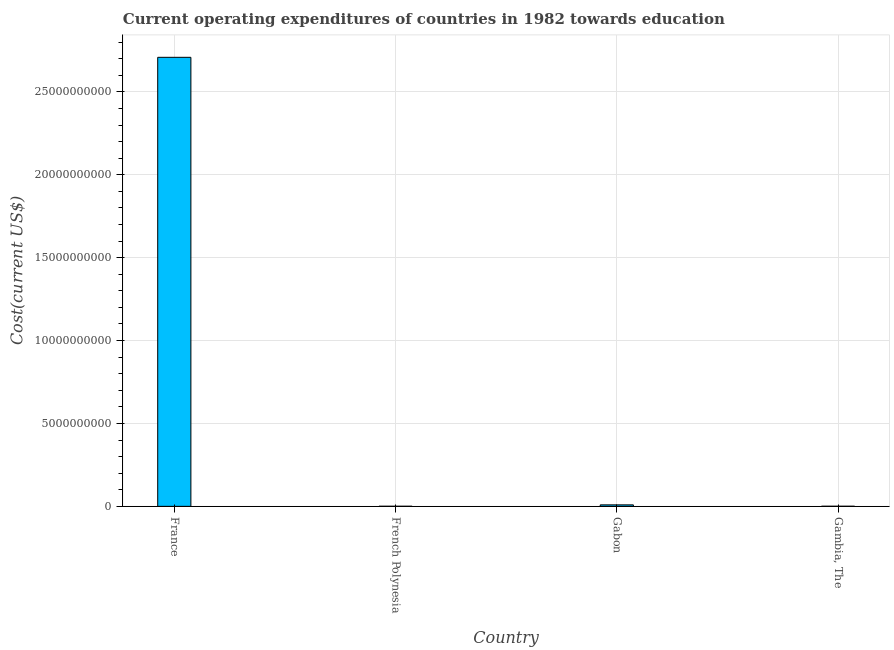Does the graph contain grids?
Provide a short and direct response. Yes. What is the title of the graph?
Provide a short and direct response. Current operating expenditures of countries in 1982 towards education. What is the label or title of the X-axis?
Keep it short and to the point. Country. What is the label or title of the Y-axis?
Your response must be concise. Cost(current US$). What is the education expenditure in Gambia, The?
Provide a succinct answer. 6.18e+06. Across all countries, what is the maximum education expenditure?
Your answer should be compact. 2.71e+1. Across all countries, what is the minimum education expenditure?
Provide a succinct answer. 5.22e+06. In which country was the education expenditure minimum?
Your answer should be compact. French Polynesia. What is the sum of the education expenditure?
Offer a very short reply. 2.72e+1. What is the difference between the education expenditure in French Polynesia and Gambia, The?
Your answer should be very brief. -9.63e+05. What is the average education expenditure per country?
Your answer should be compact. 6.80e+09. What is the median education expenditure?
Provide a short and direct response. 4.77e+07. In how many countries, is the education expenditure greater than 5000000000 US$?
Ensure brevity in your answer.  1. What is the ratio of the education expenditure in French Polynesia to that in Gabon?
Give a very brief answer. 0.06. Is the education expenditure in Gabon less than that in Gambia, The?
Provide a short and direct response. No. What is the difference between the highest and the second highest education expenditure?
Give a very brief answer. 2.70e+1. Is the sum of the education expenditure in French Polynesia and Gabon greater than the maximum education expenditure across all countries?
Your response must be concise. No. What is the difference between the highest and the lowest education expenditure?
Offer a very short reply. 2.71e+1. How many bars are there?
Provide a succinct answer. 4. How many countries are there in the graph?
Offer a terse response. 4. What is the difference between two consecutive major ticks on the Y-axis?
Give a very brief answer. 5.00e+09. Are the values on the major ticks of Y-axis written in scientific E-notation?
Ensure brevity in your answer.  No. What is the Cost(current US$) of France?
Give a very brief answer. 2.71e+1. What is the Cost(current US$) of French Polynesia?
Keep it short and to the point. 5.22e+06. What is the Cost(current US$) in Gabon?
Offer a very short reply. 8.92e+07. What is the Cost(current US$) in Gambia, The?
Keep it short and to the point. 6.18e+06. What is the difference between the Cost(current US$) in France and French Polynesia?
Keep it short and to the point. 2.71e+1. What is the difference between the Cost(current US$) in France and Gabon?
Make the answer very short. 2.70e+1. What is the difference between the Cost(current US$) in France and Gambia, The?
Keep it short and to the point. 2.71e+1. What is the difference between the Cost(current US$) in French Polynesia and Gabon?
Your response must be concise. -8.40e+07. What is the difference between the Cost(current US$) in French Polynesia and Gambia, The?
Offer a very short reply. -9.63e+05. What is the difference between the Cost(current US$) in Gabon and Gambia, The?
Provide a short and direct response. 8.30e+07. What is the ratio of the Cost(current US$) in France to that in French Polynesia?
Offer a very short reply. 5187.87. What is the ratio of the Cost(current US$) in France to that in Gabon?
Your response must be concise. 303.51. What is the ratio of the Cost(current US$) in France to that in Gambia, The?
Give a very brief answer. 4379.78. What is the ratio of the Cost(current US$) in French Polynesia to that in Gabon?
Make the answer very short. 0.06. What is the ratio of the Cost(current US$) in French Polynesia to that in Gambia, The?
Provide a succinct answer. 0.84. What is the ratio of the Cost(current US$) in Gabon to that in Gambia, The?
Provide a succinct answer. 14.43. 